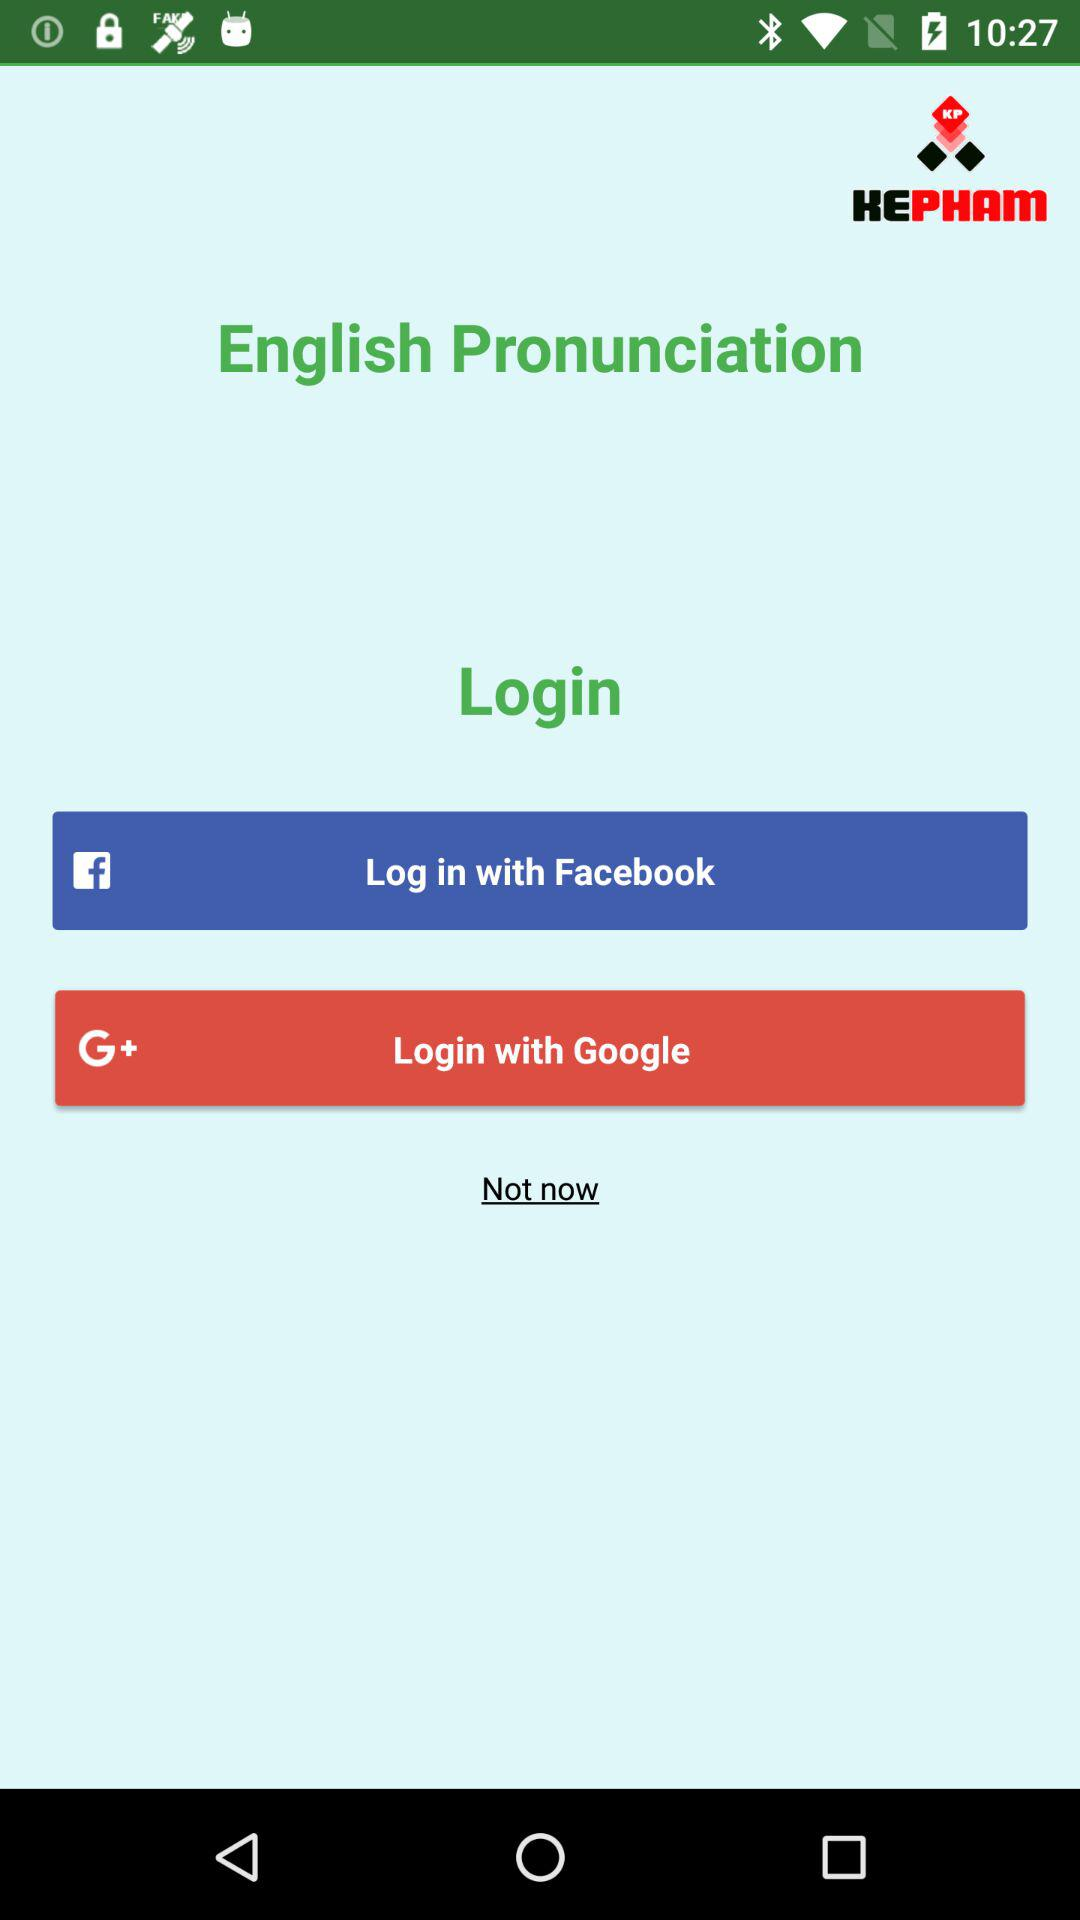What is the app name? The app name is "English Pronunciation". 